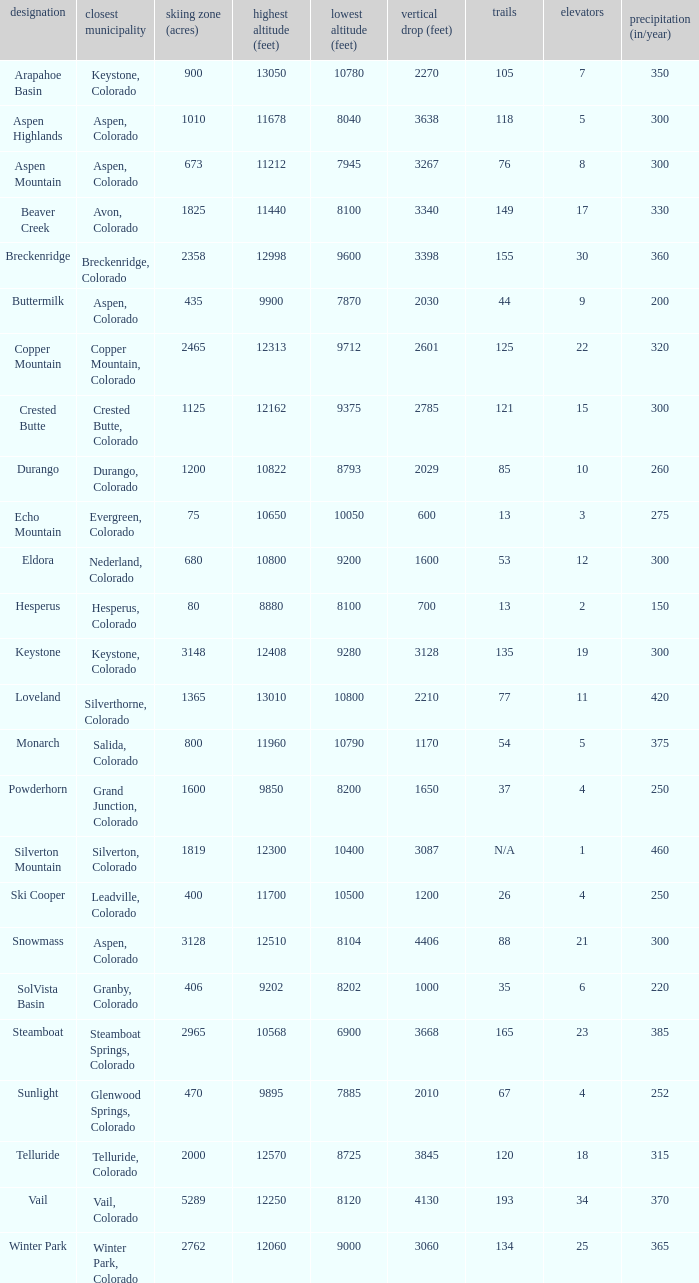If there are 30 lifts, what is the name of the ski resort? Breckenridge. 